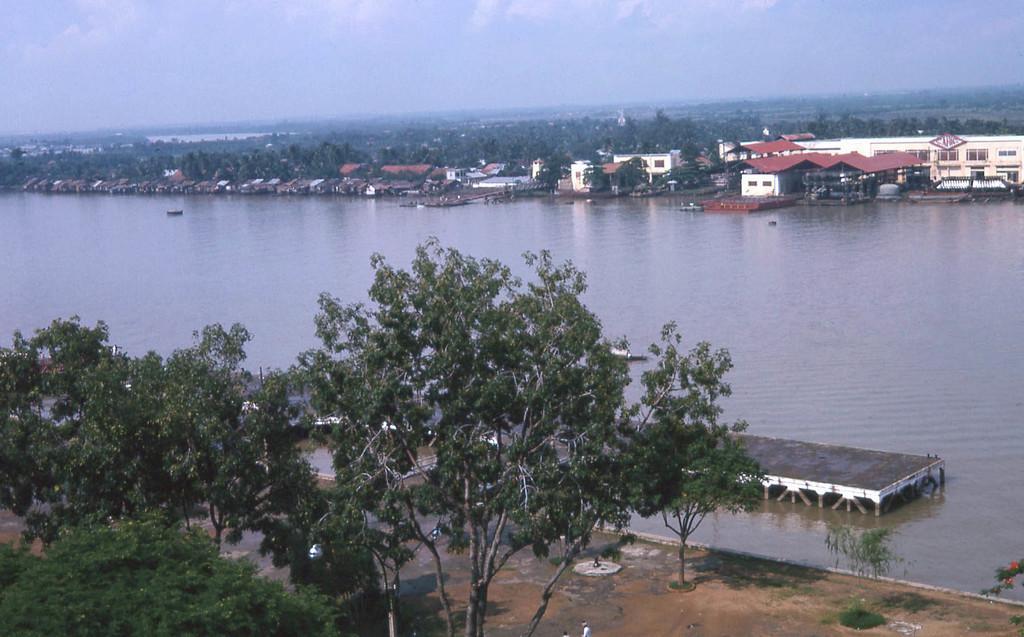In one or two sentences, can you explain what this image depicts? In the picture we can see some trees on the path and behind the path we can see water and far away we can see some boats and behind it, we can see houses, trees, some buildings and in the background also we can see full of trees and sky with clouds. 